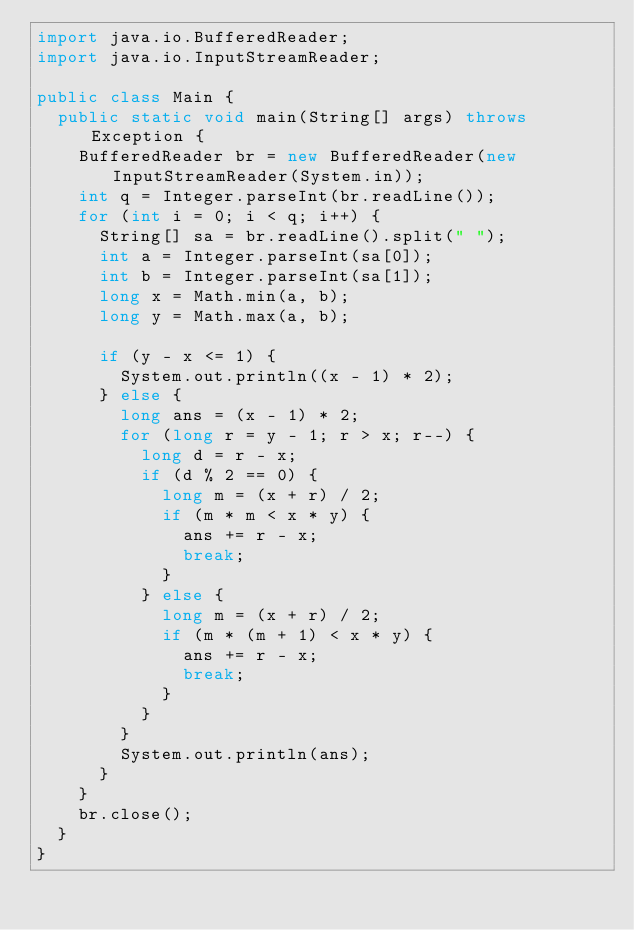Convert code to text. <code><loc_0><loc_0><loc_500><loc_500><_Java_>import java.io.BufferedReader;
import java.io.InputStreamReader;

public class Main {
	public static void main(String[] args) throws Exception {
		BufferedReader br = new BufferedReader(new InputStreamReader(System.in));
		int q = Integer.parseInt(br.readLine());
		for (int i = 0; i < q; i++) {
			String[] sa = br.readLine().split(" ");
			int a = Integer.parseInt(sa[0]);
			int b = Integer.parseInt(sa[1]);
			long x = Math.min(a, b);
			long y = Math.max(a, b);

			if (y - x <= 1) {
				System.out.println((x - 1) * 2);
			} else {
				long ans = (x - 1) * 2;
				for (long r = y - 1; r > x; r--) {
					long d = r - x;
					if (d % 2 == 0) {
						long m = (x + r) / 2;
						if (m * m < x * y) {
							ans += r - x;
							break;
						}
					} else {
						long m = (x + r) / 2;
						if (m * (m + 1) < x * y) {
							ans += r - x;
							break;
						}
					}
				}
				System.out.println(ans);
			}
		}
		br.close();
	}
}
</code> 